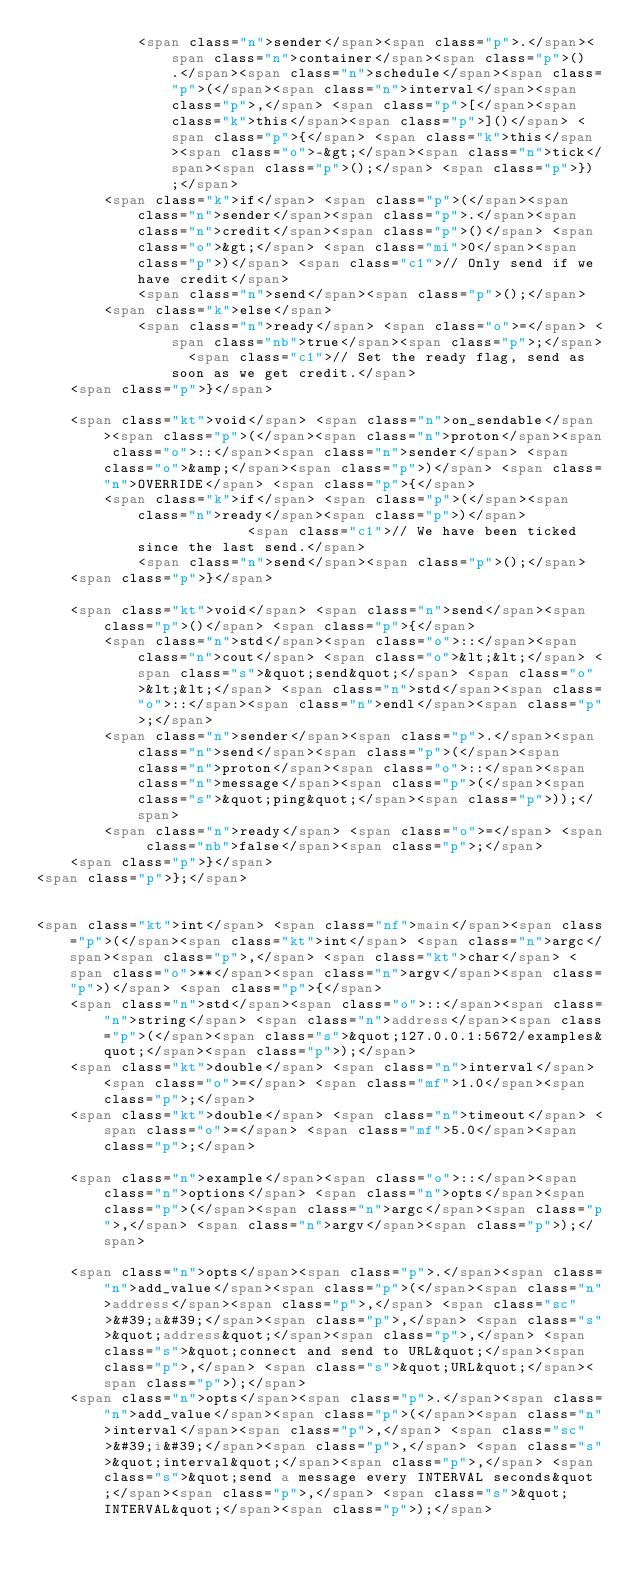<code> <loc_0><loc_0><loc_500><loc_500><_HTML_>            <span class="n">sender</span><span class="p">.</span><span class="n">container</span><span class="p">().</span><span class="n">schedule</span><span class="p">(</span><span class="n">interval</span><span class="p">,</span> <span class="p">[</span><span class="k">this</span><span class="p">]()</span> <span class="p">{</span> <span class="k">this</span><span class="o">-&gt;</span><span class="n">tick</span><span class="p">();</span> <span class="p">});</span>
        <span class="k">if</span> <span class="p">(</span><span class="n">sender</span><span class="p">.</span><span class="n">credit</span><span class="p">()</span> <span class="o">&gt;</span> <span class="mi">0</span><span class="p">)</span> <span class="c1">// Only send if we have credit</span>
            <span class="n">send</span><span class="p">();</span>
        <span class="k">else</span>
            <span class="n">ready</span> <span class="o">=</span> <span class="nb">true</span><span class="p">;</span>  <span class="c1">// Set the ready flag, send as soon as we get credit.</span>
    <span class="p">}</span>

    <span class="kt">void</span> <span class="n">on_sendable</span><span class="p">(</span><span class="n">proton</span><span class="o">::</span><span class="n">sender</span> <span class="o">&amp;</span><span class="p">)</span> <span class="n">OVERRIDE</span> <span class="p">{</span>
        <span class="k">if</span> <span class="p">(</span><span class="n">ready</span><span class="p">)</span>              <span class="c1">// We have been ticked since the last send.</span>
            <span class="n">send</span><span class="p">();</span>
    <span class="p">}</span>

    <span class="kt">void</span> <span class="n">send</span><span class="p">()</span> <span class="p">{</span>
        <span class="n">std</span><span class="o">::</span><span class="n">cout</span> <span class="o">&lt;&lt;</span> <span class="s">&quot;send&quot;</span> <span class="o">&lt;&lt;</span> <span class="n">std</span><span class="o">::</span><span class="n">endl</span><span class="p">;</span>
        <span class="n">sender</span><span class="p">.</span><span class="n">send</span><span class="p">(</span><span class="n">proton</span><span class="o">::</span><span class="n">message</span><span class="p">(</span><span class="s">&quot;ping&quot;</span><span class="p">));</span>
        <span class="n">ready</span> <span class="o">=</span> <span class="nb">false</span><span class="p">;</span>
    <span class="p">}</span>
<span class="p">};</span>


<span class="kt">int</span> <span class="nf">main</span><span class="p">(</span><span class="kt">int</span> <span class="n">argc</span><span class="p">,</span> <span class="kt">char</span> <span class="o">**</span><span class="n">argv</span><span class="p">)</span> <span class="p">{</span>
    <span class="n">std</span><span class="o">::</span><span class="n">string</span> <span class="n">address</span><span class="p">(</span><span class="s">&quot;127.0.0.1:5672/examples&quot;</span><span class="p">);</span>
    <span class="kt">double</span> <span class="n">interval</span> <span class="o">=</span> <span class="mf">1.0</span><span class="p">;</span>
    <span class="kt">double</span> <span class="n">timeout</span> <span class="o">=</span> <span class="mf">5.0</span><span class="p">;</span>

    <span class="n">example</span><span class="o">::</span><span class="n">options</span> <span class="n">opts</span><span class="p">(</span><span class="n">argc</span><span class="p">,</span> <span class="n">argv</span><span class="p">);</span>

    <span class="n">opts</span><span class="p">.</span><span class="n">add_value</span><span class="p">(</span><span class="n">address</span><span class="p">,</span> <span class="sc">&#39;a&#39;</span><span class="p">,</span> <span class="s">&quot;address&quot;</span><span class="p">,</span> <span class="s">&quot;connect and send to URL&quot;</span><span class="p">,</span> <span class="s">&quot;URL&quot;</span><span class="p">);</span>
    <span class="n">opts</span><span class="p">.</span><span class="n">add_value</span><span class="p">(</span><span class="n">interval</span><span class="p">,</span> <span class="sc">&#39;i&#39;</span><span class="p">,</span> <span class="s">&quot;interval&quot;</span><span class="p">,</span> <span class="s">&quot;send a message every INTERVAL seconds&quot;</span><span class="p">,</span> <span class="s">&quot;INTERVAL&quot;</span><span class="p">);</span></code> 